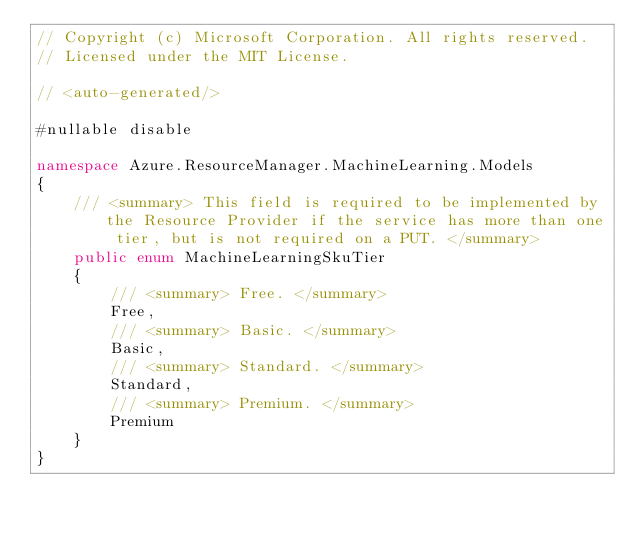Convert code to text. <code><loc_0><loc_0><loc_500><loc_500><_C#_>// Copyright (c) Microsoft Corporation. All rights reserved.
// Licensed under the MIT License.

// <auto-generated/>

#nullable disable

namespace Azure.ResourceManager.MachineLearning.Models
{
    /// <summary> This field is required to be implemented by the Resource Provider if the service has more than one tier, but is not required on a PUT. </summary>
    public enum MachineLearningSkuTier
    {
        /// <summary> Free. </summary>
        Free,
        /// <summary> Basic. </summary>
        Basic,
        /// <summary> Standard. </summary>
        Standard,
        /// <summary> Premium. </summary>
        Premium
    }
}
</code> 